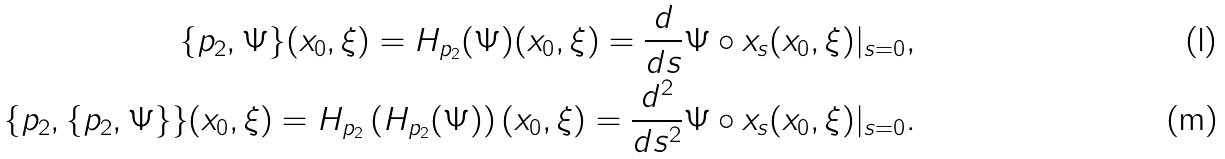Convert formula to latex. <formula><loc_0><loc_0><loc_500><loc_500>\{ p _ { 2 } , \Psi \} ( x _ { 0 } , \xi ) = H _ { p _ { 2 } } ( \Psi ) ( x _ { 0 } , \xi ) = \frac { d } { d s } \Psi \circ x _ { s } ( x _ { 0 } , \xi ) | _ { s = 0 } , \\ \{ p _ { 2 } , \{ p _ { 2 } , \Psi \} \} ( x _ { 0 } , \xi ) = H _ { p _ { 2 } } \left ( H _ { p _ { 2 } } ( \Psi ) \right ) ( x _ { 0 } , \xi ) = \frac { d ^ { 2 } } { d s ^ { 2 } } \Psi \circ x _ { s } ( x _ { 0 } , \xi ) | _ { s = 0 } .</formula> 